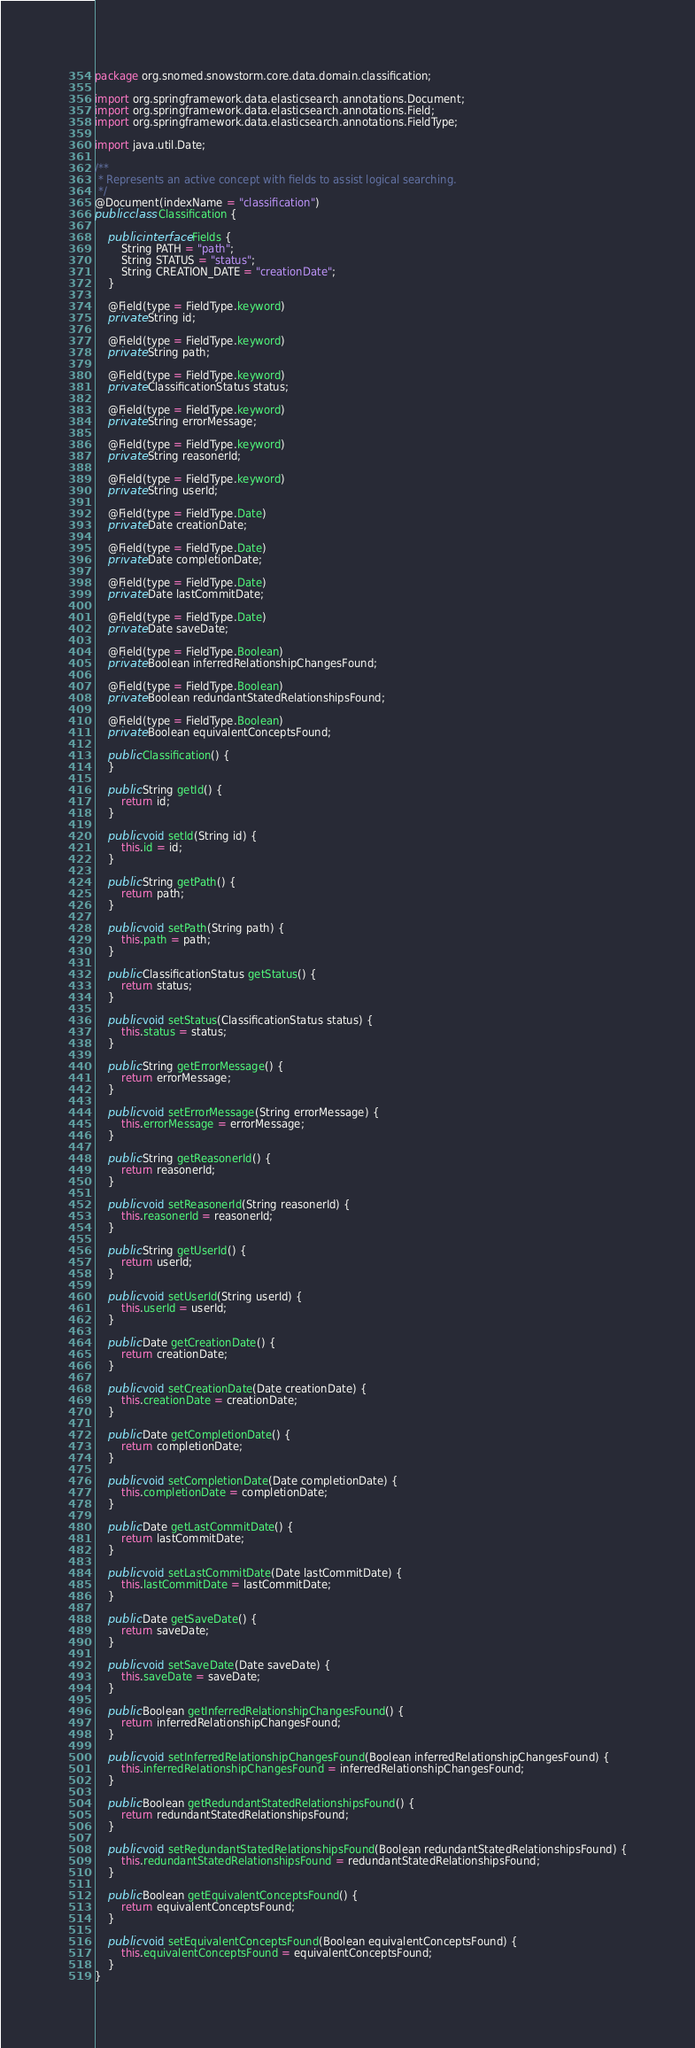Convert code to text. <code><loc_0><loc_0><loc_500><loc_500><_Java_>package org.snomed.snowstorm.core.data.domain.classification;

import org.springframework.data.elasticsearch.annotations.Document;
import org.springframework.data.elasticsearch.annotations.Field;
import org.springframework.data.elasticsearch.annotations.FieldType;

import java.util.Date;

/**
 * Represents an active concept with fields to assist logical searching.
 */
@Document(indexName = "classification")
public class Classification {

	public interface Fields {
		String PATH = "path";
		String STATUS = "status";
		String CREATION_DATE = "creationDate";
	}

	@Field(type = FieldType.keyword)
	private String id;

	@Field(type = FieldType.keyword)
	private String path;

	@Field(type = FieldType.keyword)
	private ClassificationStatus status;

	@Field(type = FieldType.keyword)
	private String errorMessage;

	@Field(type = FieldType.keyword)
	private String reasonerId;

	@Field(type = FieldType.keyword)
	private String userId;

	@Field(type = FieldType.Date)
	private Date creationDate;

	@Field(type = FieldType.Date)
	private Date completionDate;

	@Field(type = FieldType.Date)
	private Date lastCommitDate;

	@Field(type = FieldType.Date)
	private Date saveDate;

	@Field(type = FieldType.Boolean)
	private Boolean inferredRelationshipChangesFound;

	@Field(type = FieldType.Boolean)
	private Boolean redundantStatedRelationshipsFound;

	@Field(type = FieldType.Boolean)
	private Boolean equivalentConceptsFound;

	public Classification() {
	}

	public String getId() {
		return id;
	}

	public void setId(String id) {
		this.id = id;
	}

	public String getPath() {
		return path;
	}

	public void setPath(String path) {
		this.path = path;
	}

	public ClassificationStatus getStatus() {
		return status;
	}

	public void setStatus(ClassificationStatus status) {
		this.status = status;
	}

	public String getErrorMessage() {
		return errorMessage;
	}

	public void setErrorMessage(String errorMessage) {
		this.errorMessage = errorMessage;
	}

	public String getReasonerId() {
		return reasonerId;
	}

	public void setReasonerId(String reasonerId) {
		this.reasonerId = reasonerId;
	}

	public String getUserId() {
		return userId;
	}

	public void setUserId(String userId) {
		this.userId = userId;
	}

	public Date getCreationDate() {
		return creationDate;
	}

	public void setCreationDate(Date creationDate) {
		this.creationDate = creationDate;
	}

	public Date getCompletionDate() {
		return completionDate;
	}

	public void setCompletionDate(Date completionDate) {
		this.completionDate = completionDate;
	}

	public Date getLastCommitDate() {
		return lastCommitDate;
	}

	public void setLastCommitDate(Date lastCommitDate) {
		this.lastCommitDate = lastCommitDate;
	}

	public Date getSaveDate() {
		return saveDate;
	}

	public void setSaveDate(Date saveDate) {
		this.saveDate = saveDate;
	}

	public Boolean getInferredRelationshipChangesFound() {
		return inferredRelationshipChangesFound;
	}

	public void setInferredRelationshipChangesFound(Boolean inferredRelationshipChangesFound) {
		this.inferredRelationshipChangesFound = inferredRelationshipChangesFound;
	}

	public Boolean getRedundantStatedRelationshipsFound() {
		return redundantStatedRelationshipsFound;
	}

	public void setRedundantStatedRelationshipsFound(Boolean redundantStatedRelationshipsFound) {
		this.redundantStatedRelationshipsFound = redundantStatedRelationshipsFound;
	}

	public Boolean getEquivalentConceptsFound() {
		return equivalentConceptsFound;
	}

	public void setEquivalentConceptsFound(Boolean equivalentConceptsFound) {
		this.equivalentConceptsFound = equivalentConceptsFound;
	}
}
</code> 